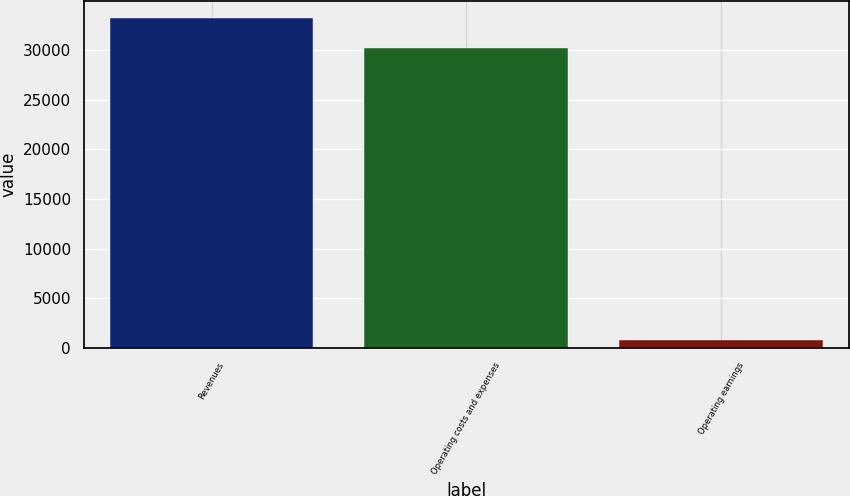Convert chart. <chart><loc_0><loc_0><loc_500><loc_500><bar_chart><fcel>Revenues<fcel>Operating costs and expenses<fcel>Operating earnings<nl><fcel>33249.7<fcel>30227<fcel>765<nl></chart> 